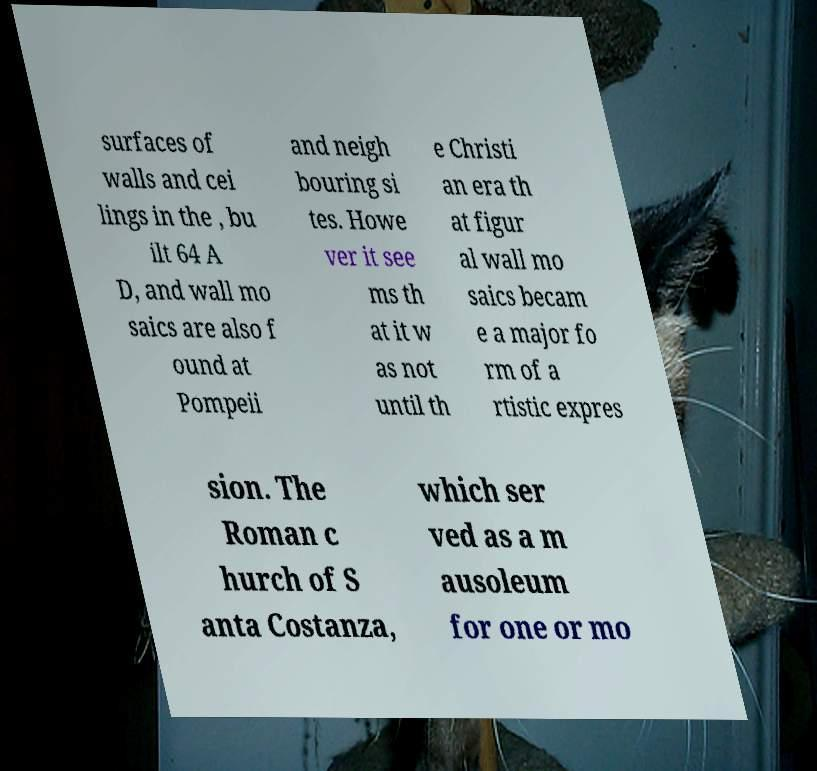I need the written content from this picture converted into text. Can you do that? surfaces of walls and cei lings in the , bu ilt 64 A D, and wall mo saics are also f ound at Pompeii and neigh bouring si tes. Howe ver it see ms th at it w as not until th e Christi an era th at figur al wall mo saics becam e a major fo rm of a rtistic expres sion. The Roman c hurch of S anta Costanza, which ser ved as a m ausoleum for one or mo 